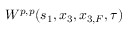Convert formula to latex. <formula><loc_0><loc_0><loc_500><loc_500>W ^ { p , p } ( s _ { 1 } , x _ { 3 } , x _ { 3 , F } , \tau )</formula> 